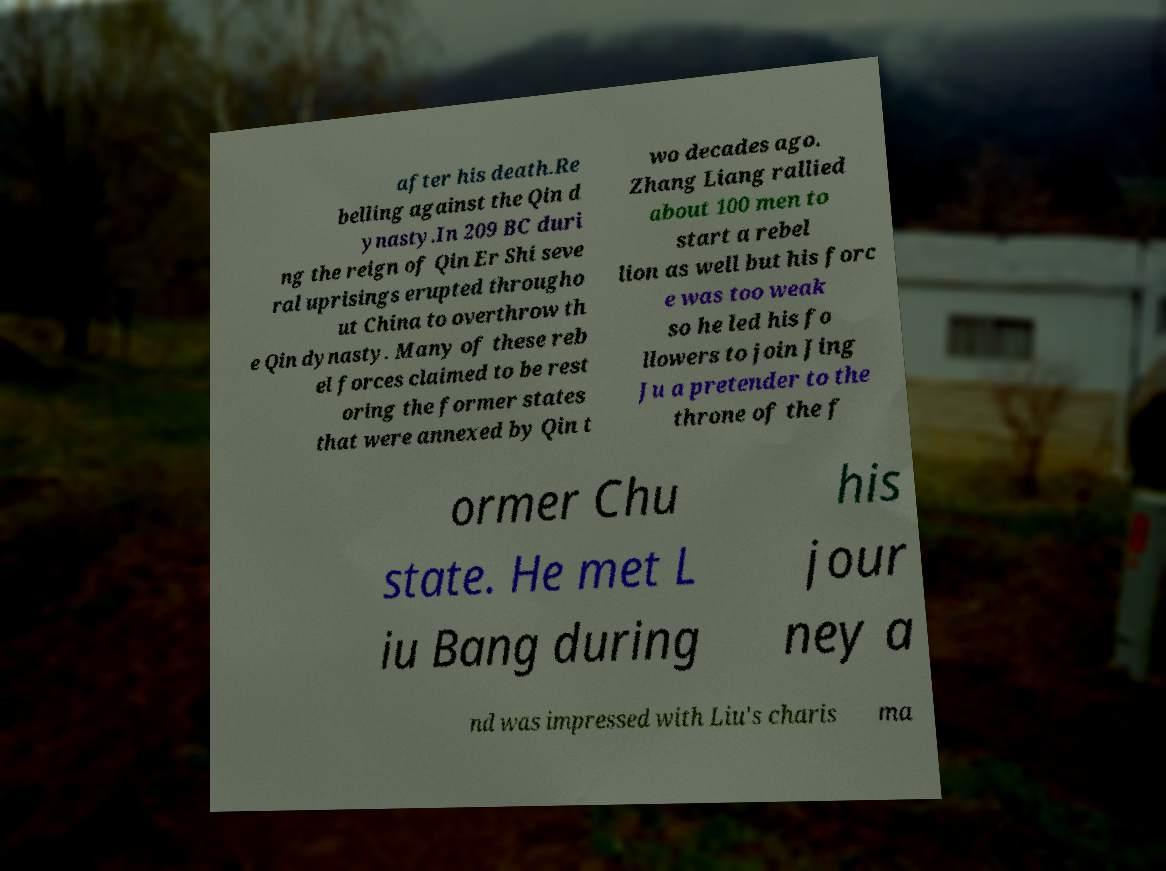For documentation purposes, I need the text within this image transcribed. Could you provide that? after his death.Re belling against the Qin d ynasty.In 209 BC duri ng the reign of Qin Er Shi seve ral uprisings erupted througho ut China to overthrow th e Qin dynasty. Many of these reb el forces claimed to be rest oring the former states that were annexed by Qin t wo decades ago. Zhang Liang rallied about 100 men to start a rebel lion as well but his forc e was too weak so he led his fo llowers to join Jing Ju a pretender to the throne of the f ormer Chu state. He met L iu Bang during his jour ney a nd was impressed with Liu's charis ma 